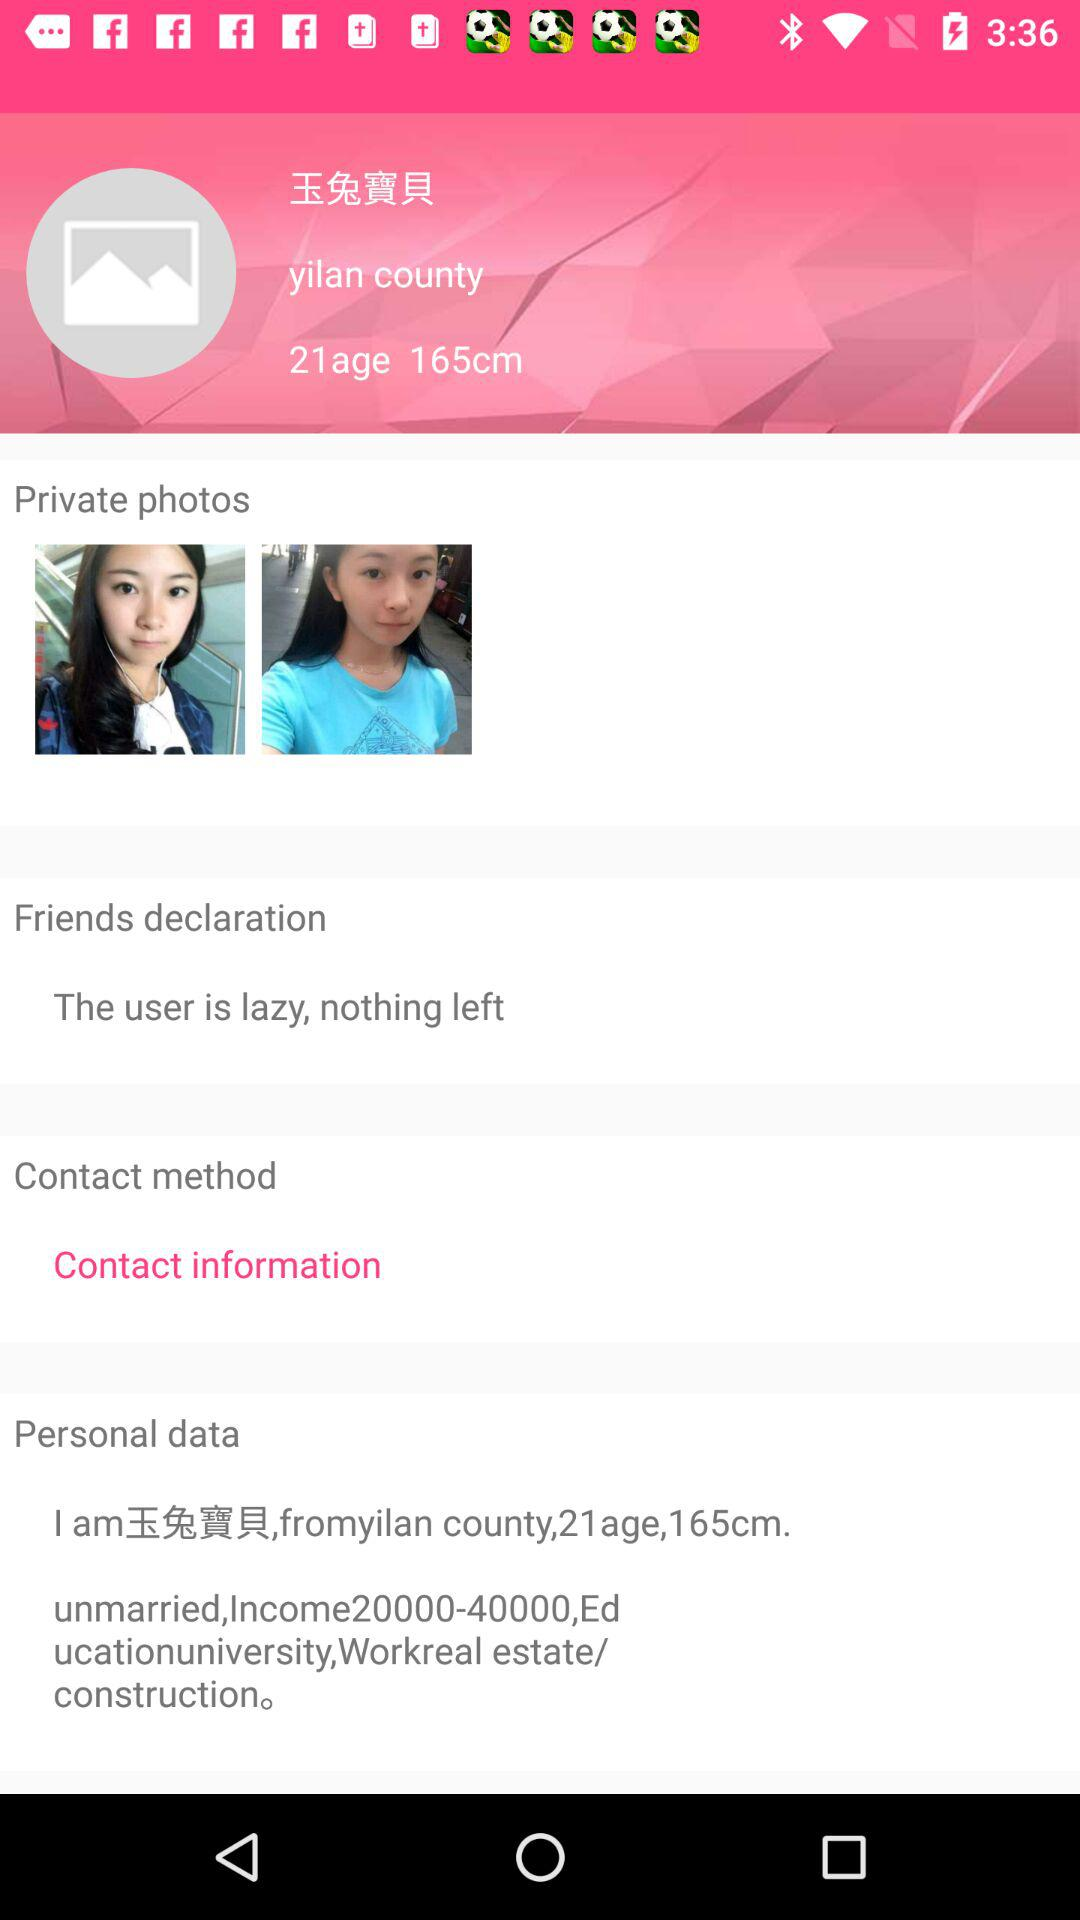What is the height? The height is 165 cm. 